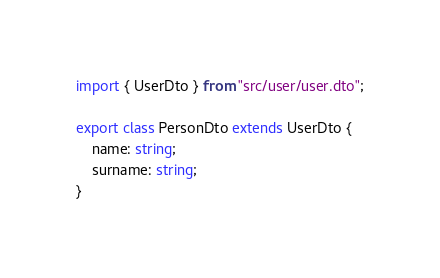<code> <loc_0><loc_0><loc_500><loc_500><_TypeScript_>import { UserDto } from "src/user/user.dto";

export class PersonDto extends UserDto {
    name: string;
    surname: string;
}
</code> 